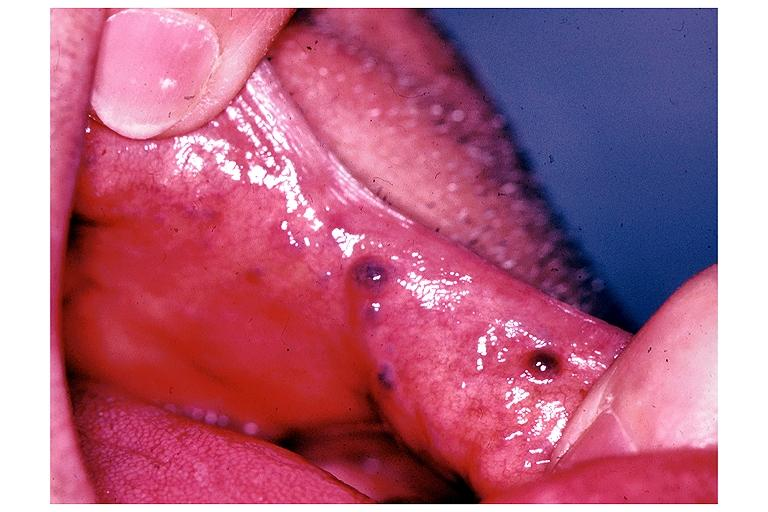s oral present?
Answer the question using a single word or phrase. Yes 